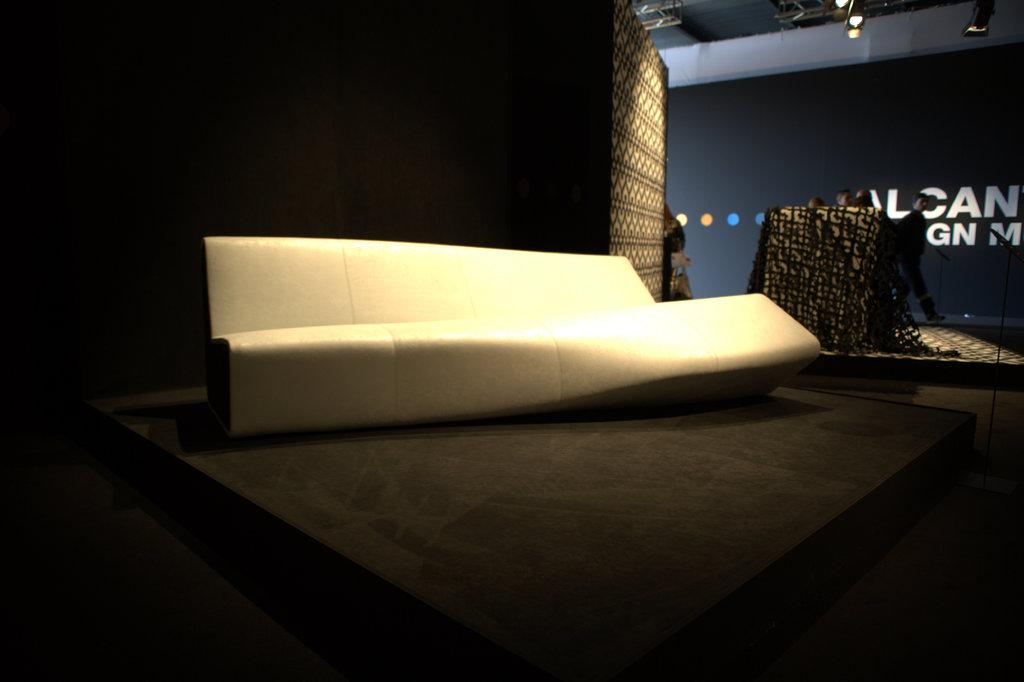What type of furniture is on the stage in the image? There is a couch on the stage in the image. Can you describe the people in the image? There are people in the image, but their specific actions or appearances are not mentioned in the facts. What can be seen in the image that provides illumination? There are lights visible in the image. What is written or displayed on the wall in the image? There is a wall with text in the image. What type of curtain is used to cover the wealth in the image? There is no mention of a curtain or wealth in the image. How many pans are visible on the stage in the image? There is no mention of pans in the image. 